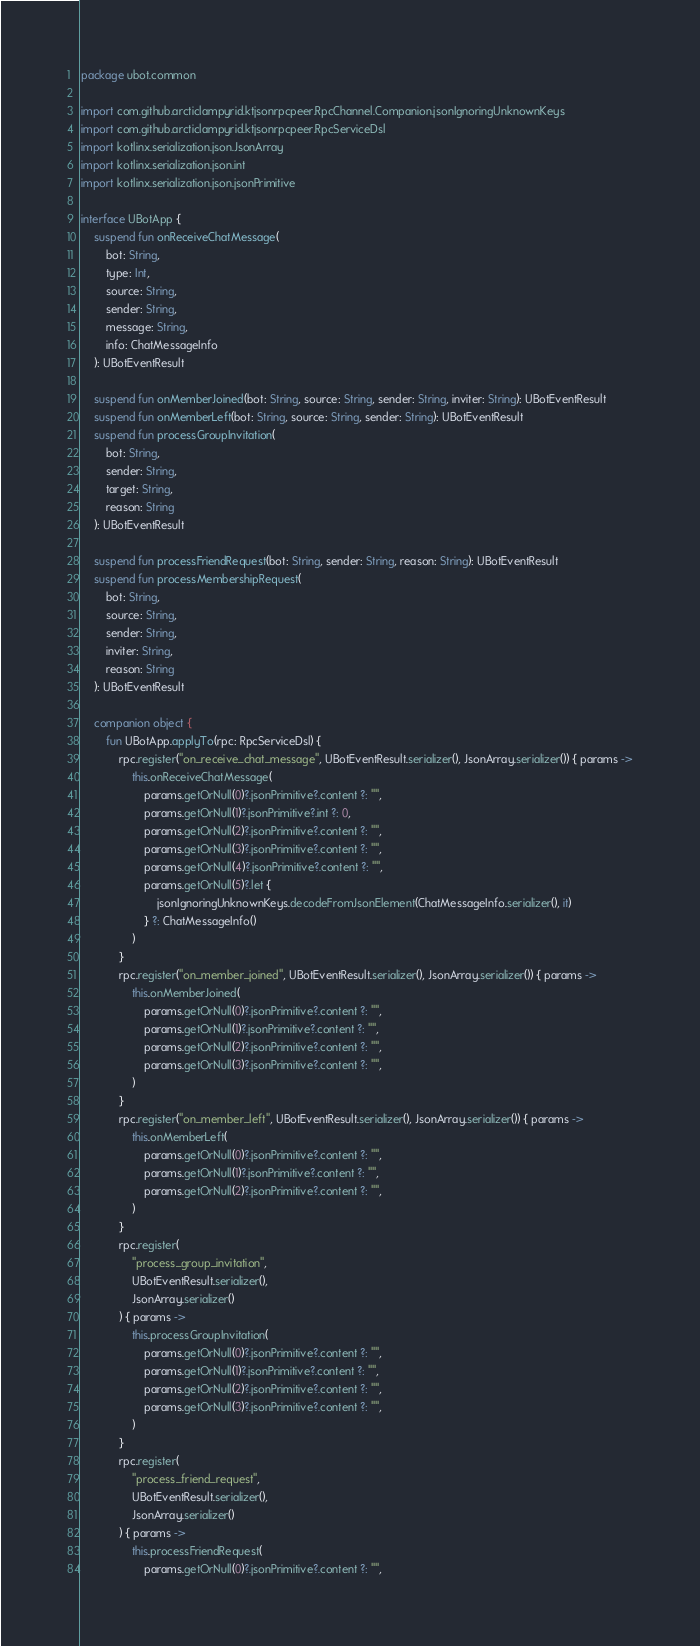<code> <loc_0><loc_0><loc_500><loc_500><_Kotlin_>package ubot.common

import com.github.arcticlampyrid.ktjsonrpcpeer.RpcChannel.Companion.jsonIgnoringUnknownKeys
import com.github.arcticlampyrid.ktjsonrpcpeer.RpcServiceDsl
import kotlinx.serialization.json.JsonArray
import kotlinx.serialization.json.int
import kotlinx.serialization.json.jsonPrimitive

interface UBotApp {
    suspend fun onReceiveChatMessage(
        bot: String,
        type: Int,
        source: String,
        sender: String,
        message: String,
        info: ChatMessageInfo
    ): UBotEventResult

    suspend fun onMemberJoined(bot: String, source: String, sender: String, inviter: String): UBotEventResult
    suspend fun onMemberLeft(bot: String, source: String, sender: String): UBotEventResult
    suspend fun processGroupInvitation(
        bot: String,
        sender: String,
        target: String,
        reason: String
    ): UBotEventResult

    suspend fun processFriendRequest(bot: String, sender: String, reason: String): UBotEventResult
    suspend fun processMembershipRequest(
        bot: String,
        source: String,
        sender: String,
        inviter: String,
        reason: String
    ): UBotEventResult

    companion object {
        fun UBotApp.applyTo(rpc: RpcServiceDsl) {
            rpc.register("on_receive_chat_message", UBotEventResult.serializer(), JsonArray.serializer()) { params ->
                this.onReceiveChatMessage(
                    params.getOrNull(0)?.jsonPrimitive?.content ?: "",
                    params.getOrNull(1)?.jsonPrimitive?.int ?: 0,
                    params.getOrNull(2)?.jsonPrimitive?.content ?: "",
                    params.getOrNull(3)?.jsonPrimitive?.content ?: "",
                    params.getOrNull(4)?.jsonPrimitive?.content ?: "",
                    params.getOrNull(5)?.let {
                        jsonIgnoringUnknownKeys.decodeFromJsonElement(ChatMessageInfo.serializer(), it)
                    } ?: ChatMessageInfo()
                )
            }
            rpc.register("on_member_joined", UBotEventResult.serializer(), JsonArray.serializer()) { params ->
                this.onMemberJoined(
                    params.getOrNull(0)?.jsonPrimitive?.content ?: "",
                    params.getOrNull(1)?.jsonPrimitive?.content ?: "",
                    params.getOrNull(2)?.jsonPrimitive?.content ?: "",
                    params.getOrNull(3)?.jsonPrimitive?.content ?: "",
                )
            }
            rpc.register("on_member_left", UBotEventResult.serializer(), JsonArray.serializer()) { params ->
                this.onMemberLeft(
                    params.getOrNull(0)?.jsonPrimitive?.content ?: "",
                    params.getOrNull(1)?.jsonPrimitive?.content ?: "",
                    params.getOrNull(2)?.jsonPrimitive?.content ?: "",
                )
            }
            rpc.register(
                "process_group_invitation",
                UBotEventResult.serializer(),
                JsonArray.serializer()
            ) { params ->
                this.processGroupInvitation(
                    params.getOrNull(0)?.jsonPrimitive?.content ?: "",
                    params.getOrNull(1)?.jsonPrimitive?.content ?: "",
                    params.getOrNull(2)?.jsonPrimitive?.content ?: "",
                    params.getOrNull(3)?.jsonPrimitive?.content ?: "",
                )
            }
            rpc.register(
                "process_friend_request",
                UBotEventResult.serializer(),
                JsonArray.serializer()
            ) { params ->
                this.processFriendRequest(
                    params.getOrNull(0)?.jsonPrimitive?.content ?: "",</code> 